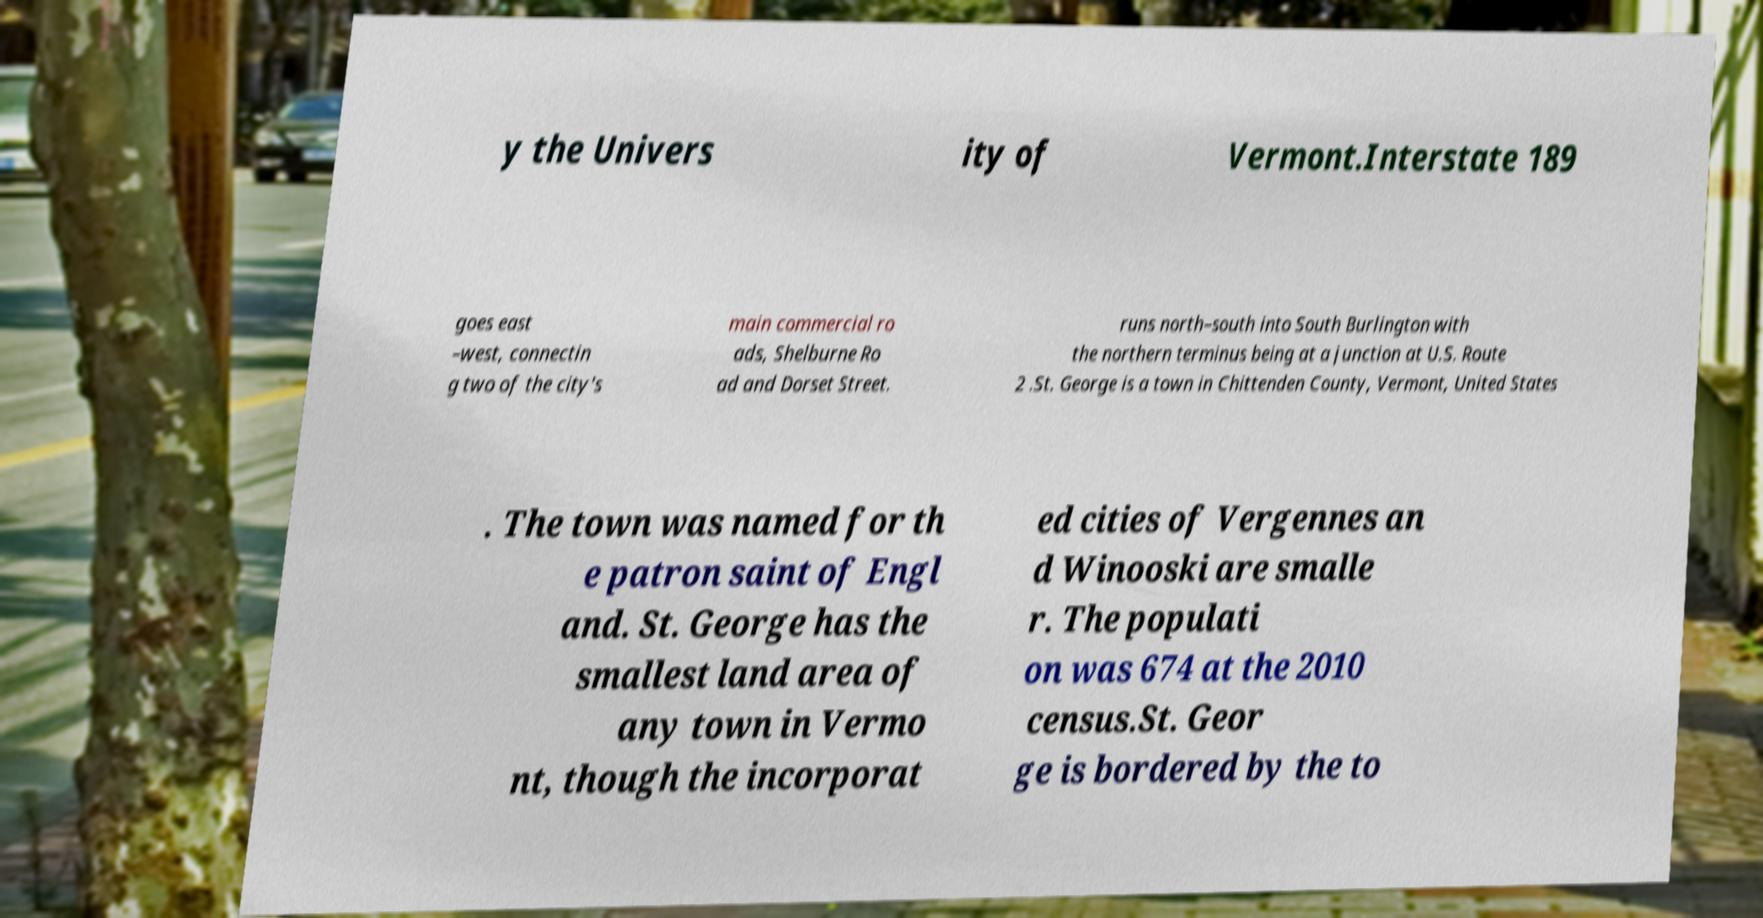I need the written content from this picture converted into text. Can you do that? y the Univers ity of Vermont.Interstate 189 goes east –west, connectin g two of the city's main commercial ro ads, Shelburne Ro ad and Dorset Street. runs north–south into South Burlington with the northern terminus being at a junction at U.S. Route 2 .St. George is a town in Chittenden County, Vermont, United States . The town was named for th e patron saint of Engl and. St. George has the smallest land area of any town in Vermo nt, though the incorporat ed cities of Vergennes an d Winooski are smalle r. The populati on was 674 at the 2010 census.St. Geor ge is bordered by the to 